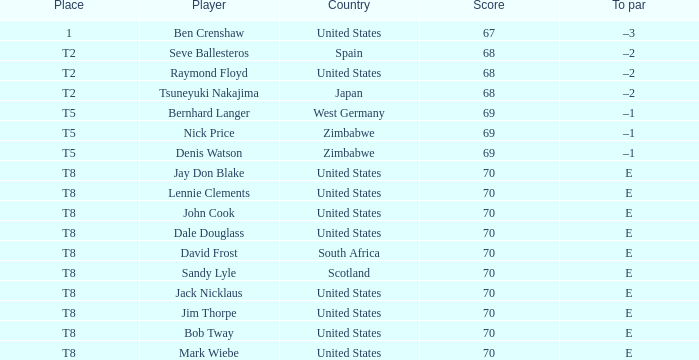Which athlete has the united states as their nation with a score of 70? Jay Don Blake, Lennie Clements, John Cook, Dale Douglass, Jack Nicklaus, Jim Thorpe, Bob Tway, Mark Wiebe. 